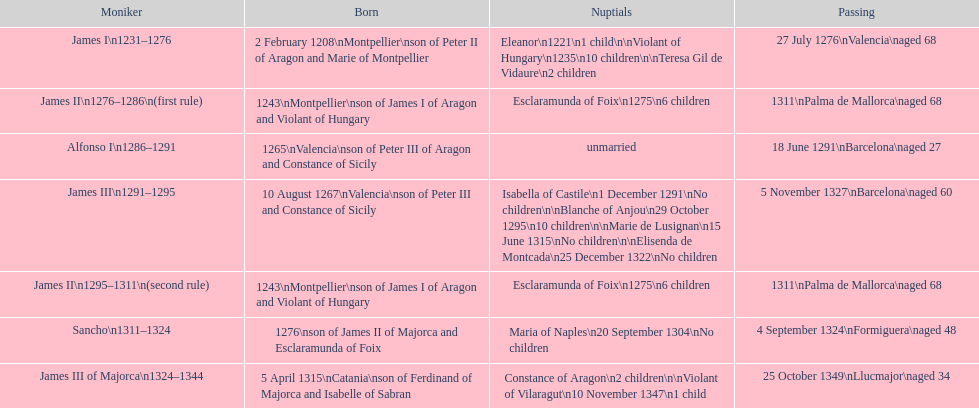Who came to power after the rule of james iii? James II. 